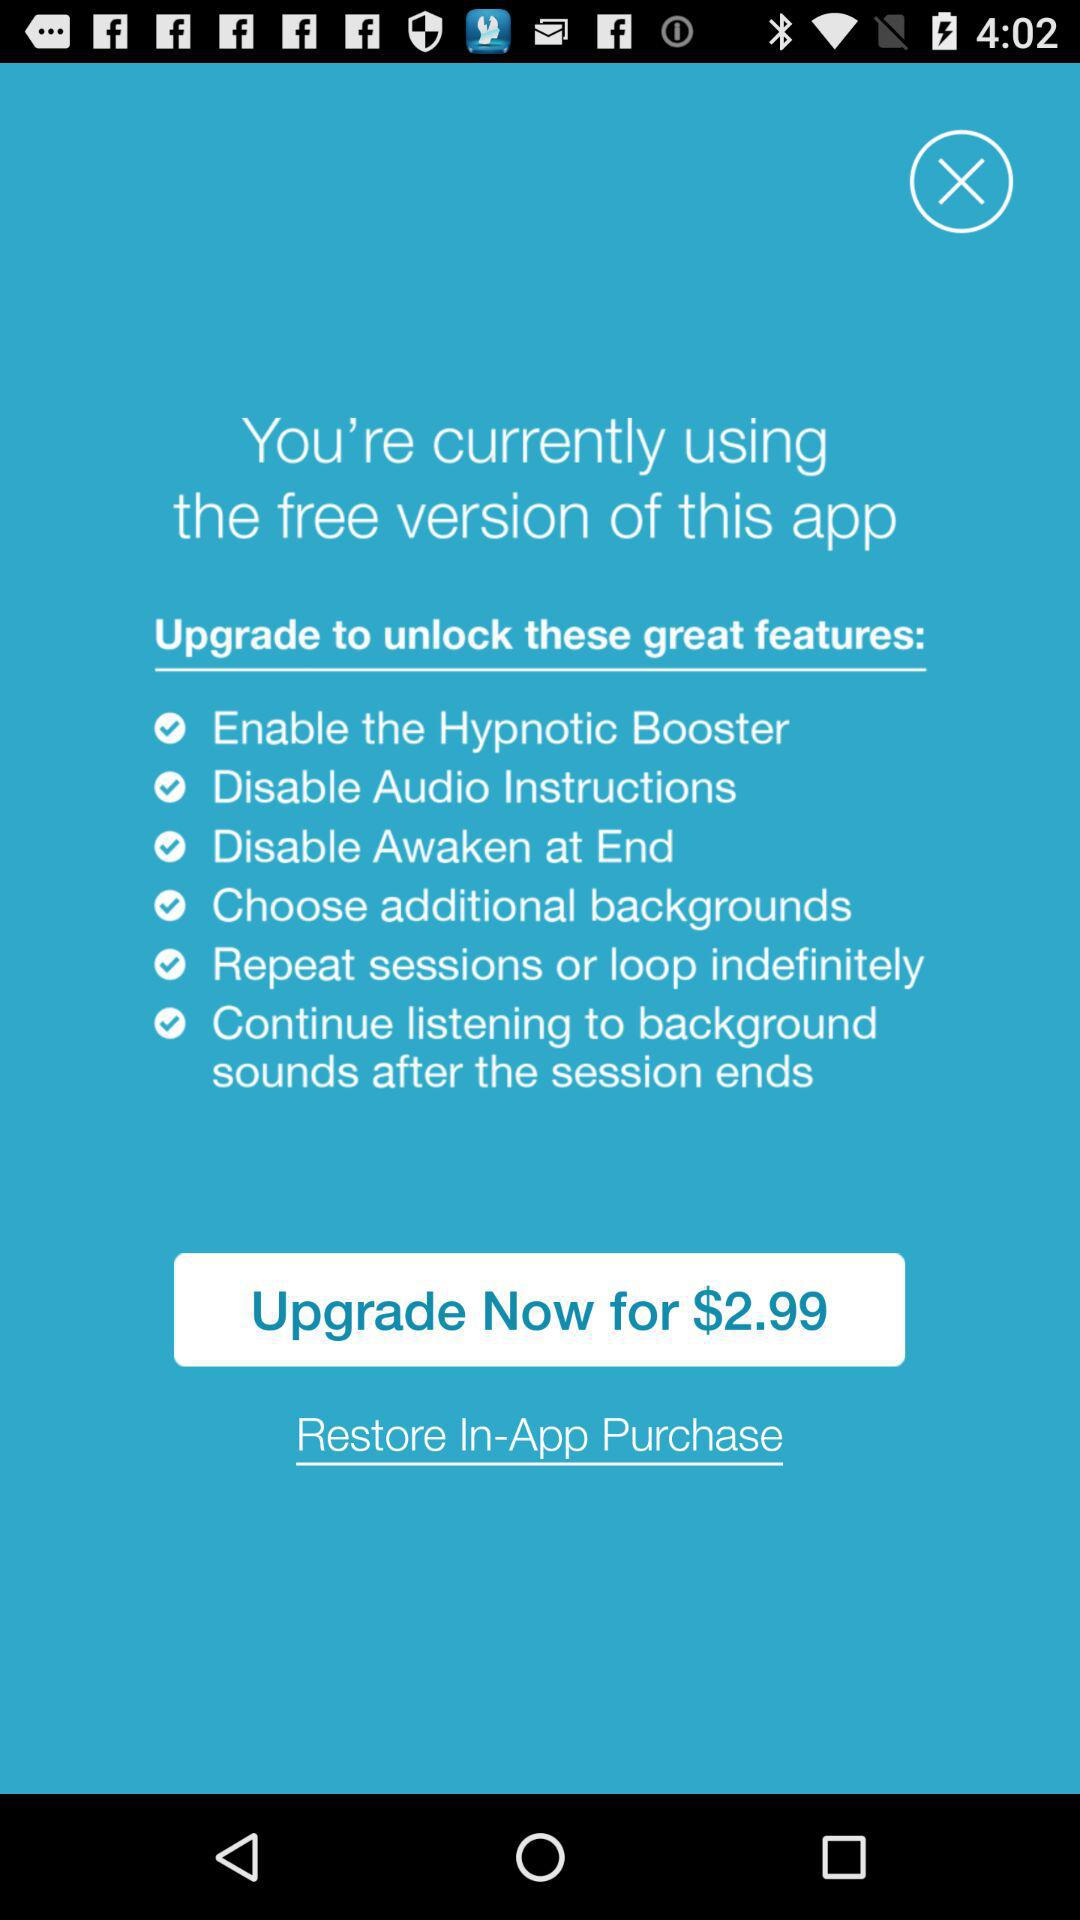What is the upgrade cost of the app? The upgrade cost of the app is $2.99. 